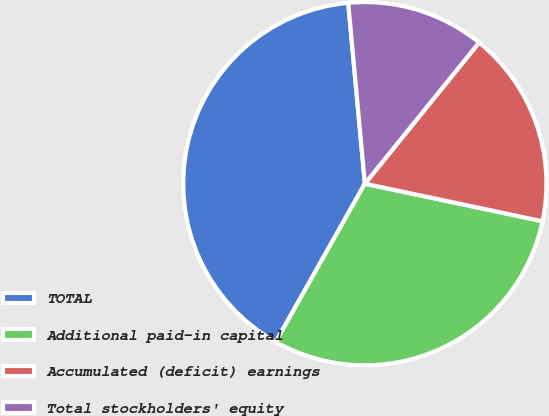Convert chart to OTSL. <chart><loc_0><loc_0><loc_500><loc_500><pie_chart><fcel>TOTAL<fcel>Additional paid-in capital<fcel>Accumulated (deficit) earnings<fcel>Total stockholders' equity<nl><fcel>40.38%<fcel>29.85%<fcel>17.49%<fcel>12.29%<nl></chart> 